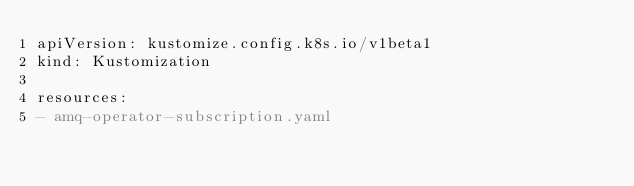Convert code to text. <code><loc_0><loc_0><loc_500><loc_500><_YAML_>apiVersion: kustomize.config.k8s.io/v1beta1
kind: Kustomization

resources:
- amq-operator-subscription.yaml</code> 